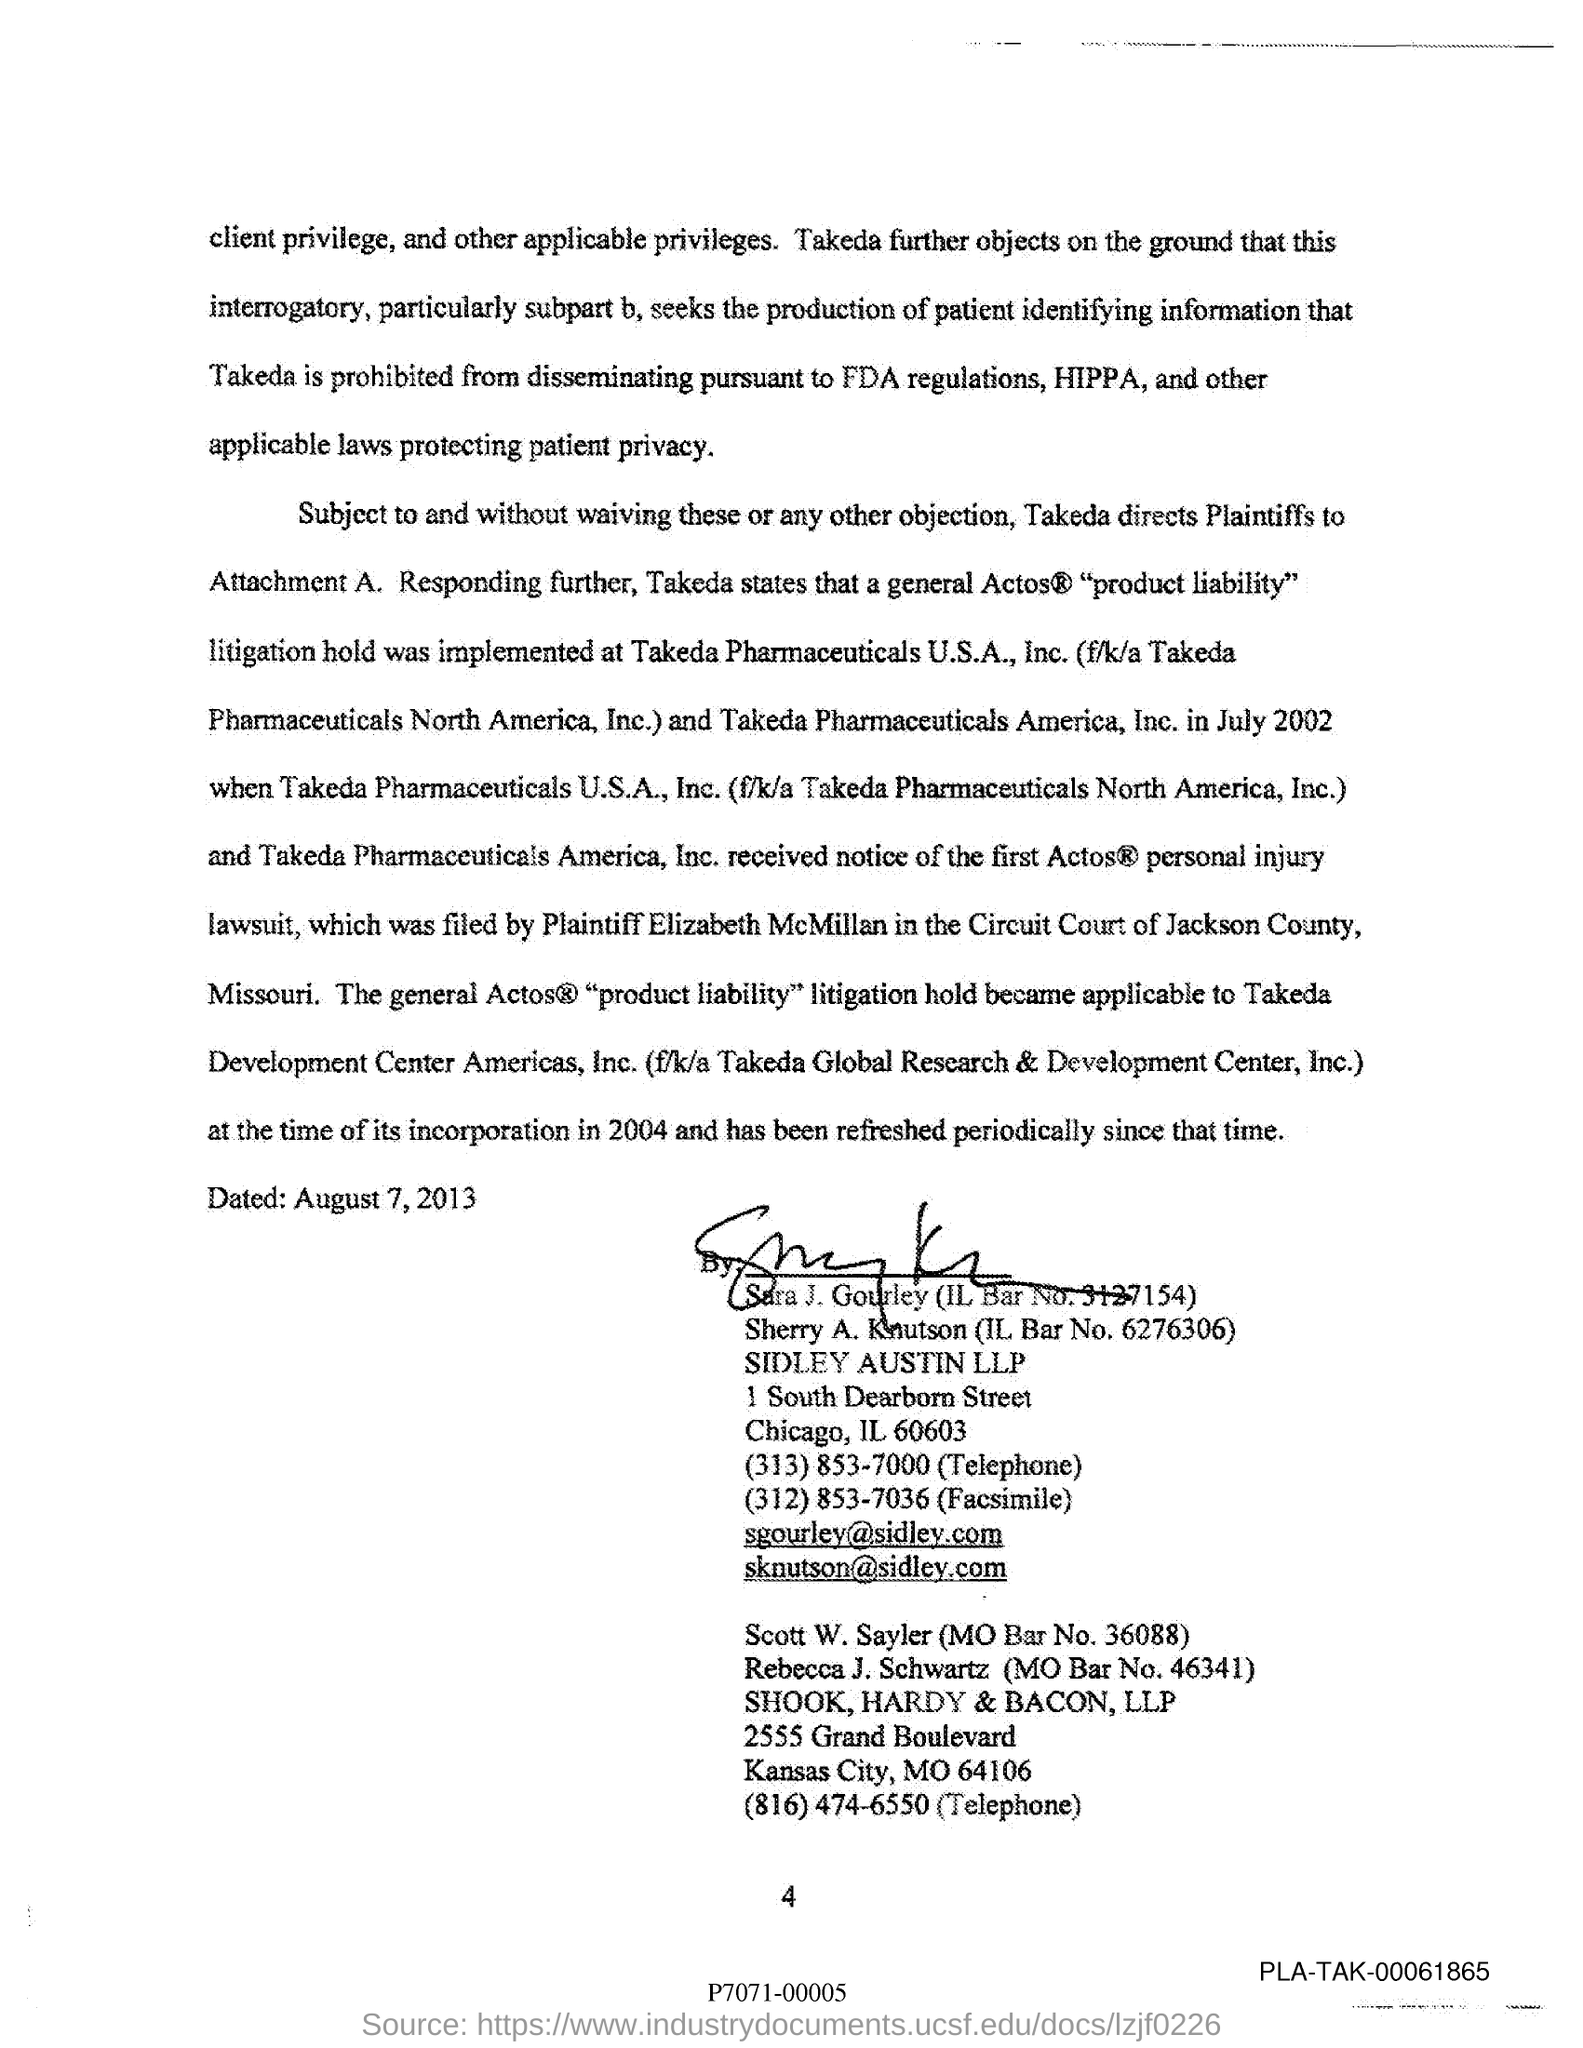Highlight a few significant elements in this photo. The email address of Sara J. Gourley is sgourley@sidley.com. The MO Bar No. of Scott W. Sayler is 36088. The IL Bar No. of Sara J. Gourley is 3127154. 